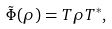Convert formula to latex. <formula><loc_0><loc_0><loc_500><loc_500>\tilde { \Phi } ( \rho ) = T \rho T ^ { \ast } ,</formula> 